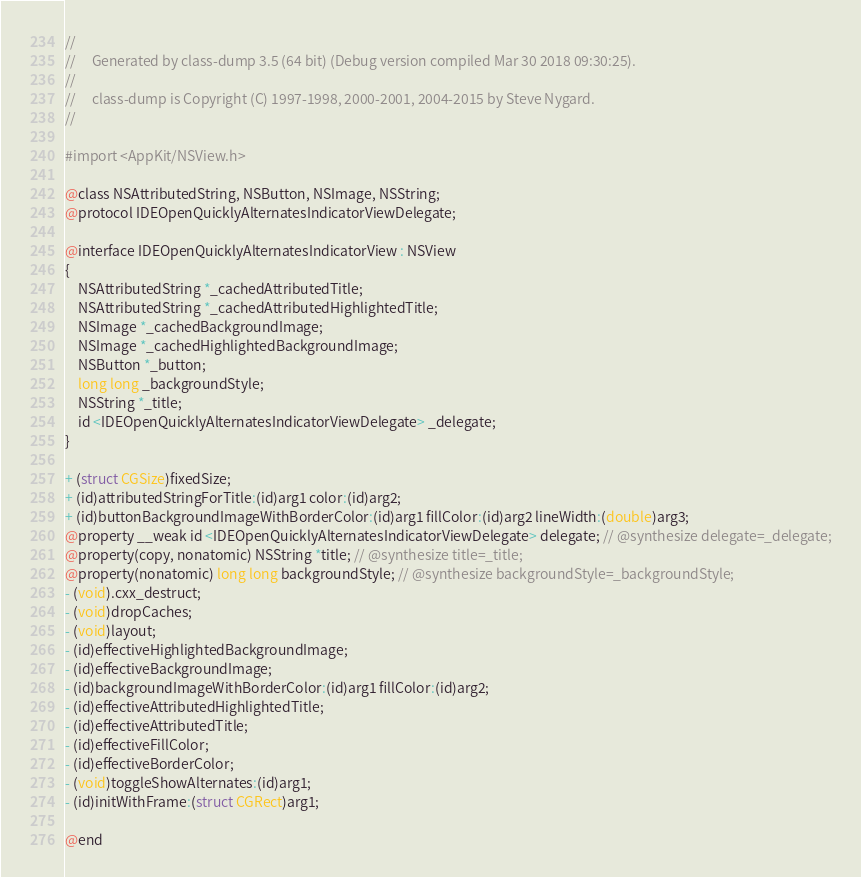Convert code to text. <code><loc_0><loc_0><loc_500><loc_500><_C_>//
//     Generated by class-dump 3.5 (64 bit) (Debug version compiled Mar 30 2018 09:30:25).
//
//     class-dump is Copyright (C) 1997-1998, 2000-2001, 2004-2015 by Steve Nygard.
//

#import <AppKit/NSView.h>

@class NSAttributedString, NSButton, NSImage, NSString;
@protocol IDEOpenQuicklyAlternatesIndicatorViewDelegate;

@interface IDEOpenQuicklyAlternatesIndicatorView : NSView
{
    NSAttributedString *_cachedAttributedTitle;
    NSAttributedString *_cachedAttributedHighlightedTitle;
    NSImage *_cachedBackgroundImage;
    NSImage *_cachedHighlightedBackgroundImage;
    NSButton *_button;
    long long _backgroundStyle;
    NSString *_title;
    id <IDEOpenQuicklyAlternatesIndicatorViewDelegate> _delegate;
}

+ (struct CGSize)fixedSize;
+ (id)attributedStringForTitle:(id)arg1 color:(id)arg2;
+ (id)buttonBackgroundImageWithBorderColor:(id)arg1 fillColor:(id)arg2 lineWidth:(double)arg3;
@property __weak id <IDEOpenQuicklyAlternatesIndicatorViewDelegate> delegate; // @synthesize delegate=_delegate;
@property(copy, nonatomic) NSString *title; // @synthesize title=_title;
@property(nonatomic) long long backgroundStyle; // @synthesize backgroundStyle=_backgroundStyle;
- (void).cxx_destruct;
- (void)dropCaches;
- (void)layout;
- (id)effectiveHighlightedBackgroundImage;
- (id)effectiveBackgroundImage;
- (id)backgroundImageWithBorderColor:(id)arg1 fillColor:(id)arg2;
- (id)effectiveAttributedHighlightedTitle;
- (id)effectiveAttributedTitle;
- (id)effectiveFillColor;
- (id)effectiveBorderColor;
- (void)toggleShowAlternates:(id)arg1;
- (id)initWithFrame:(struct CGRect)arg1;

@end

</code> 